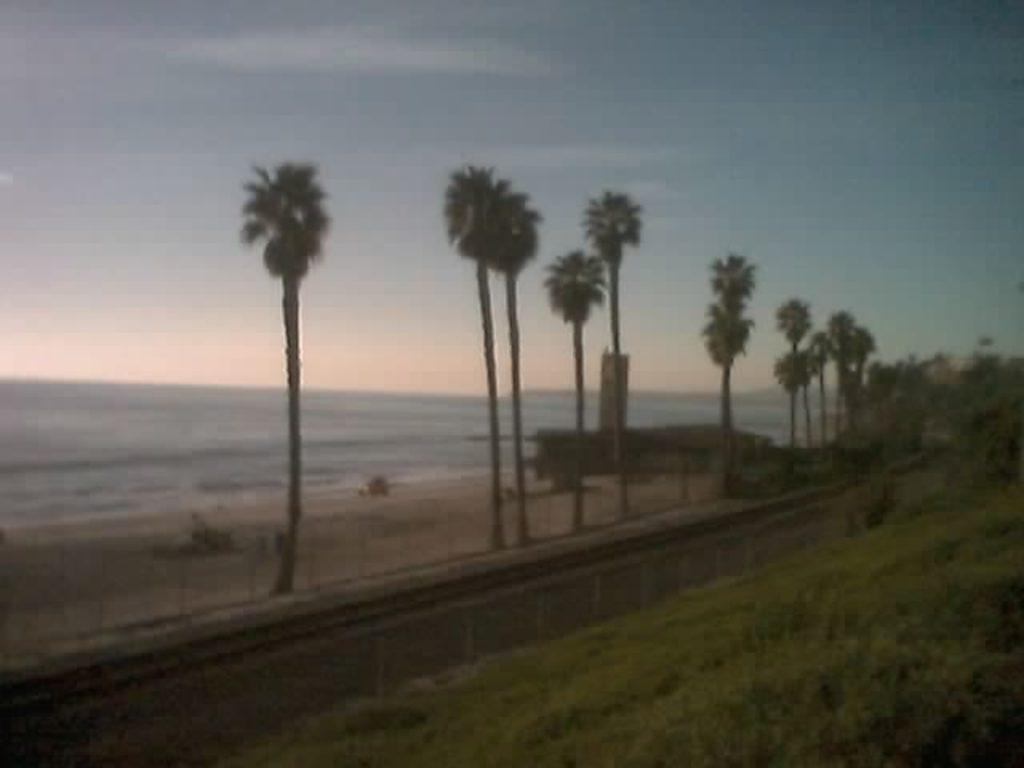What type of surface can be seen in the image? There is ground visible in the image. What type of vegetation is present in the image? There is grass in the image. What type of pathway is in the image? There is a road in the image. What type of structures are in the image? There are poles in the image. What type of natural elements are in the image? There are trees in the image. What can be seen in the distance in the image? There is water visible in the background of the image, and the sky is also visible in the background. What type of detail can be seen on the birth certificate in the image? There is no birth certificate present in the image; it features a landscape with ground, grass, road, poles, trees, water, and sky. 